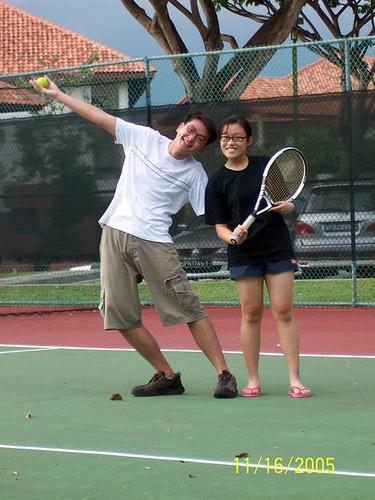How many cars can you see?
Give a very brief answer. 2. How many people are there?
Give a very brief answer. 2. 